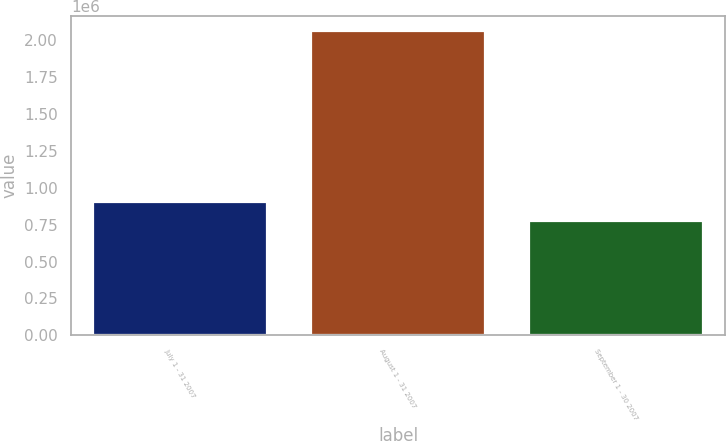Convert chart. <chart><loc_0><loc_0><loc_500><loc_500><bar_chart><fcel>July 1 - 31 2007<fcel>August 1 - 31 2007<fcel>September 1 - 30 2007<nl><fcel>906204<fcel>2.0606e+06<fcel>777938<nl></chart> 